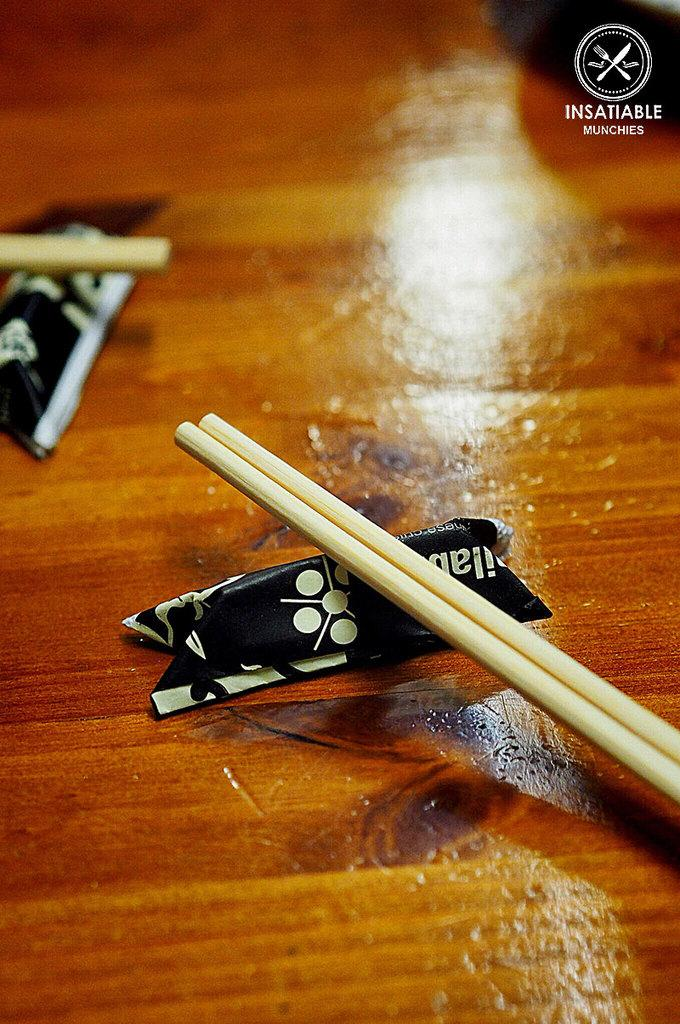What utensils are on the table in the image? There are chopsticks on the table in the image. What else is on the table besides the chopsticks? There is a paper on the table. What type of tramp can be seen in the image? There is no tramp present in the image. What is the aftermath of the car accident in the image? There is no car accident or aftermath present in the image. 